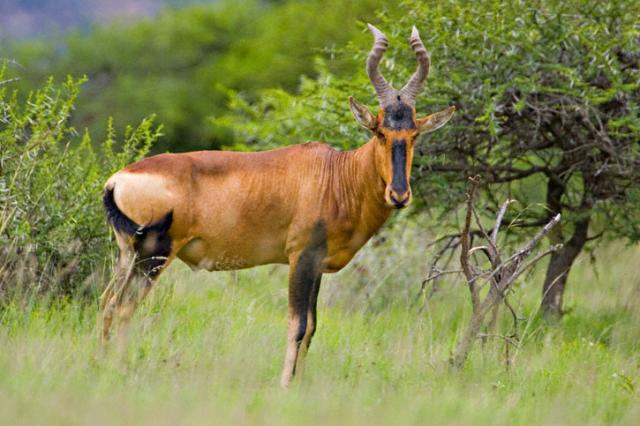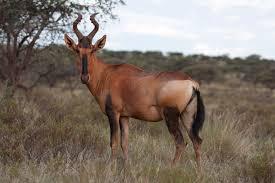The first image is the image on the left, the second image is the image on the right. Assess this claim about the two images: "There are more than two standing animals.". Correct or not? Answer yes or no. No. The first image is the image on the left, the second image is the image on the right. Considering the images on both sides, is "No photo contains more than one animal." valid? Answer yes or no. Yes. 